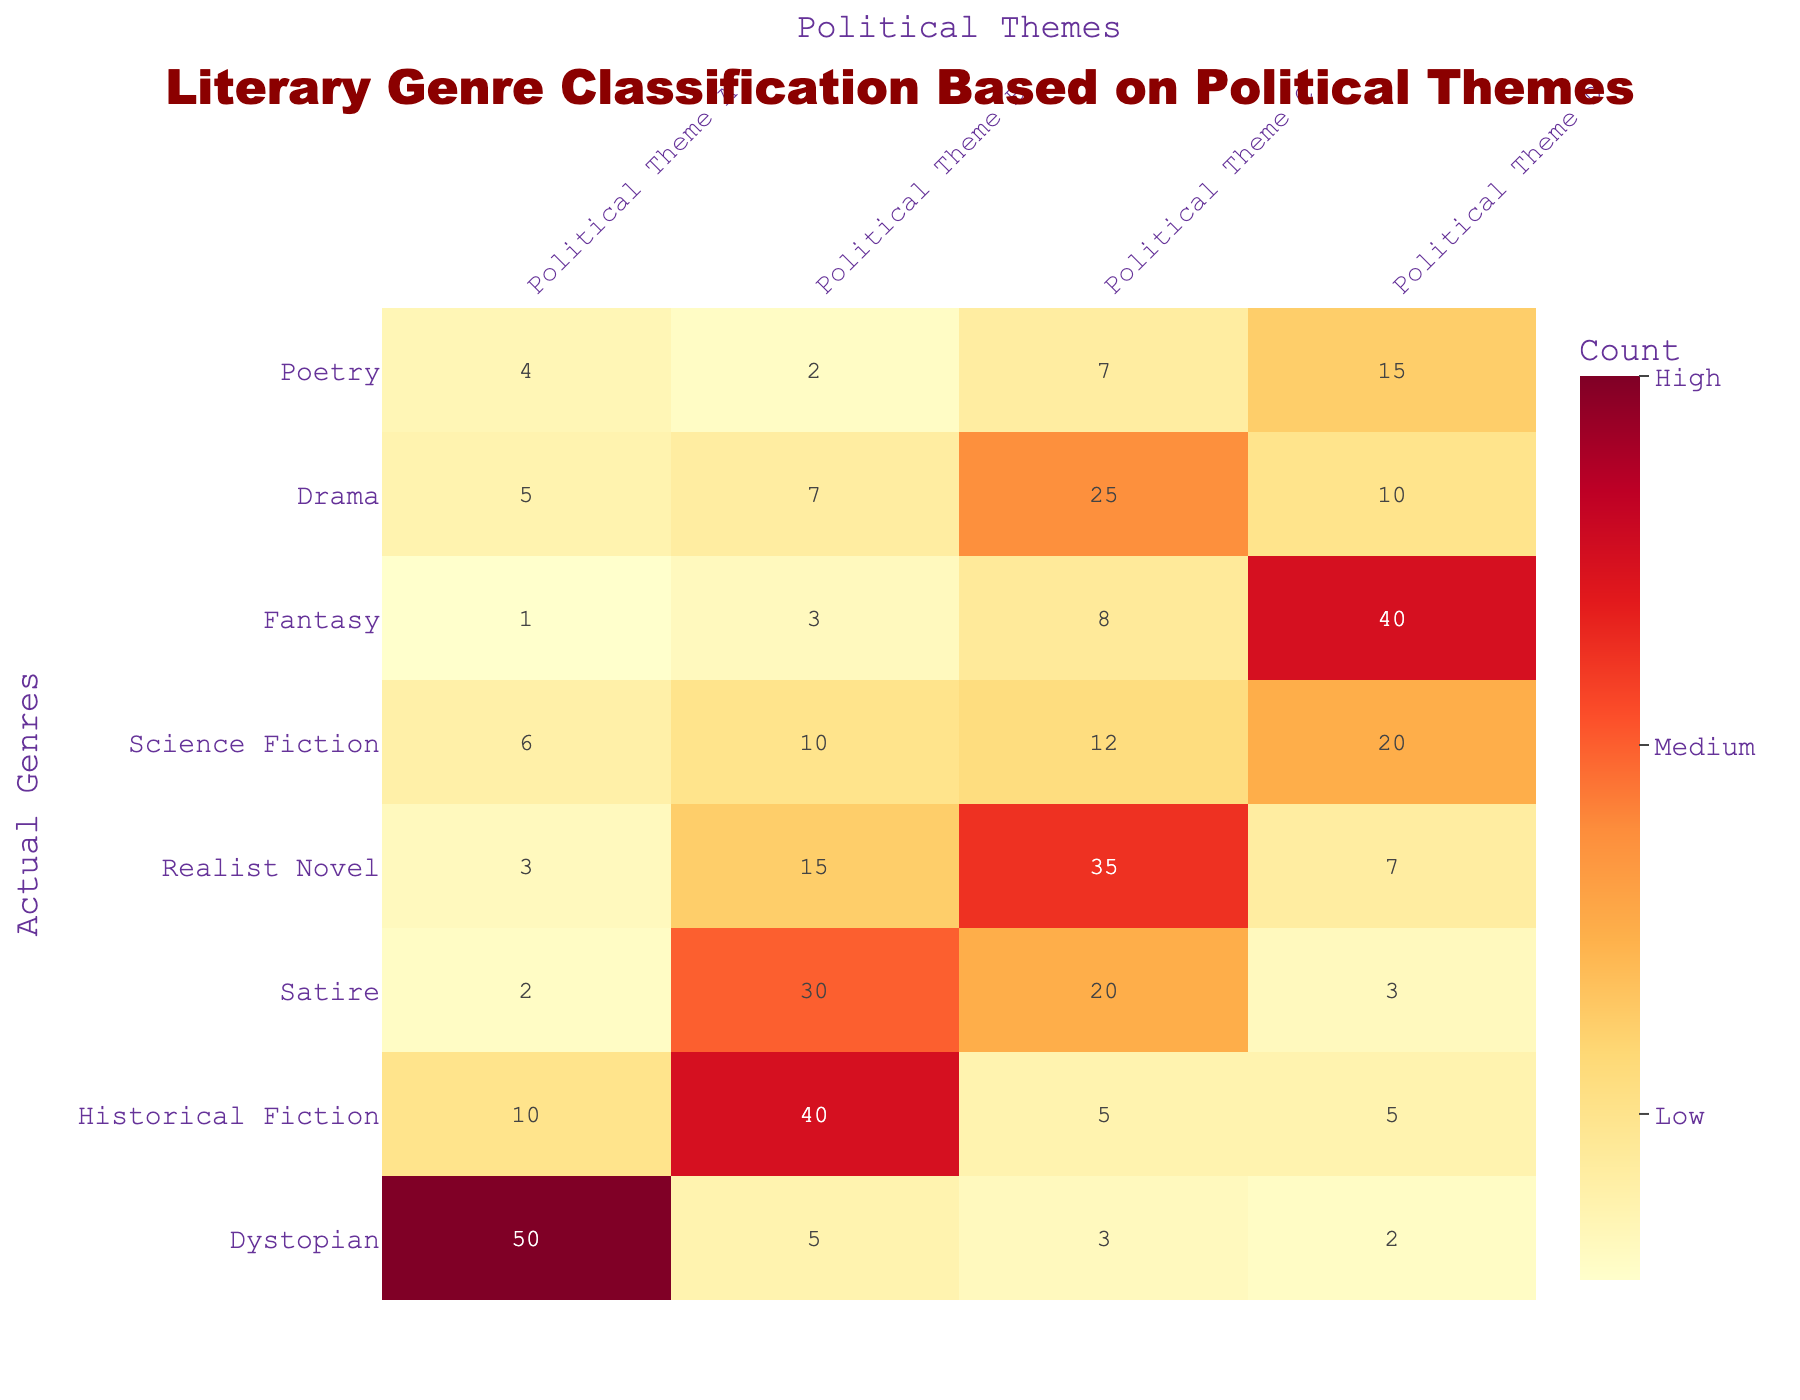What is the count for Dystopian genre in Political Theme A? The count for the Dystopian genre under Political Theme A can be directly obtained from the table. Looking at the Dystopian row and Political Theme A column, the value is 50.
Answer: 50 Which genre has the highest count for Political Theme C? To find the genre with the highest count for Political Theme C, we check each row's value in that column. The values are 3, 5, 20, 35, 12, 8, 25, and 7. The highest value is 35 for the Realist Novel genre.
Answer: Realist Novel Is the count for Fantasy genre in Political Theme D greater than that in Political Theme A? A comparison is needed between Fantasy's counts for Political Theme D and A. The count for Fantasy in Political Theme D is 40, and in Political Theme A it is 1. Since 40 is greater than 1, the statement is true.
Answer: Yes What is the total count for Historical Fiction across all political themes? To find the total count for Historical Fiction, we sum its counts across all political themes: 10 (A) + 40 (B) + 5 (C) + 5 (D) = 60. Therefore, the total count is 60.
Answer: 60 Which genre has the lowest total count across all political themes? We need to calculate the total count for each genre and compare them. The counts are: Dystopian (60), Historical Fiction (60), Satire (55), Realist Novel (60), Science Fiction (60), Fantasy (52), Drama (47), Poetry (28). The lowest total is for Poetry with a count of 28.
Answer: Poetry What is the difference in count between the highest and lowest values for Political Theme B? First, we identify the highest and lowest counts for Political Theme B. The highest is 40 (Historical Fiction) and the lowest is 2 (Poetry). The difference is 40 - 2 = 38.
Answer: 38 Does the count for Drama in Political Theme C exceed that for Science Fiction in the same theme? For Drama in Political Theme C, the count is 25, and for Science Fiction, it's 12. Since 25 is greater than 12, the statement is true.
Answer: Yes What is the average count for Political Theme D across all genres? We first find the total count for Political Theme D: 2 + 5 + 3 + 7 + 20 + 40 + 10 + 15 = 102. Then, we divide this total by the number of genres (8): 102 / 8 = 12.75.
Answer: 12.75 